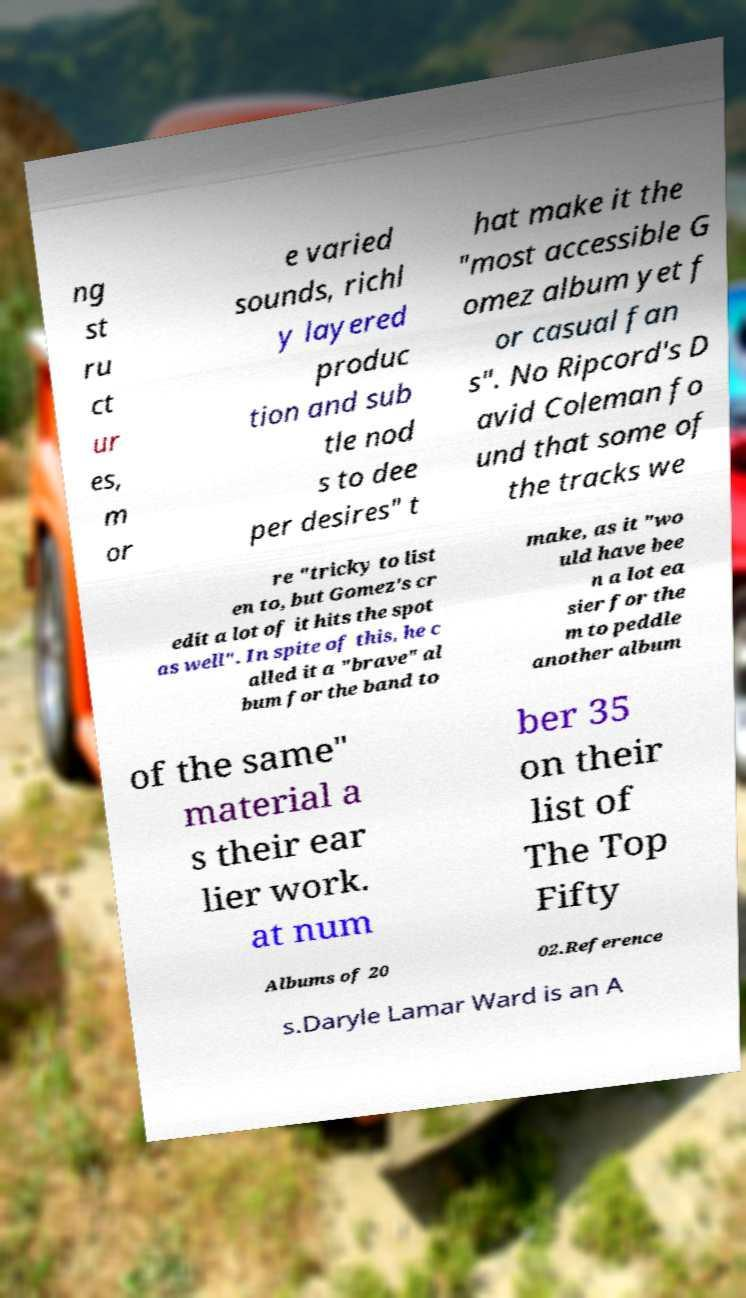Can you read and provide the text displayed in the image?This photo seems to have some interesting text. Can you extract and type it out for me? ng st ru ct ur es, m or e varied sounds, richl y layered produc tion and sub tle nod s to dee per desires" t hat make it the "most accessible G omez album yet f or casual fan s". No Ripcord's D avid Coleman fo und that some of the tracks we re "tricky to list en to, but Gomez's cr edit a lot of it hits the spot as well". In spite of this, he c alled it a "brave" al bum for the band to make, as it "wo uld have bee n a lot ea sier for the m to peddle another album of the same" material a s their ear lier work. at num ber 35 on their list of The Top Fifty Albums of 20 02.Reference s.Daryle Lamar Ward is an A 